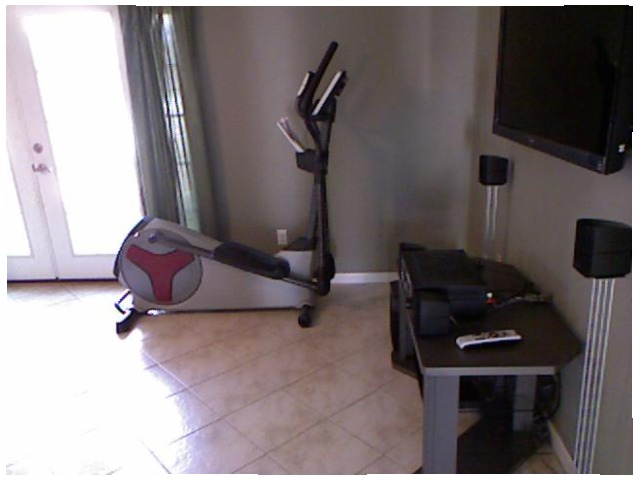<image>
Is the bicycle on the table? No. The bicycle is not positioned on the table. They may be near each other, but the bicycle is not supported by or resting on top of the table. 